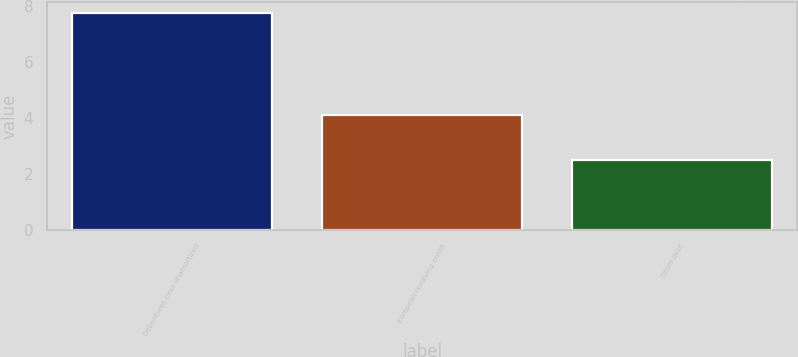Convert chart to OTSL. <chart><loc_0><loc_0><loc_500><loc_500><bar_chart><fcel>Debentures (less unamortized<fcel>European revolving credit<fcel>Other debt<nl><fcel>7.75<fcel>4.12<fcel>2.5<nl></chart> 